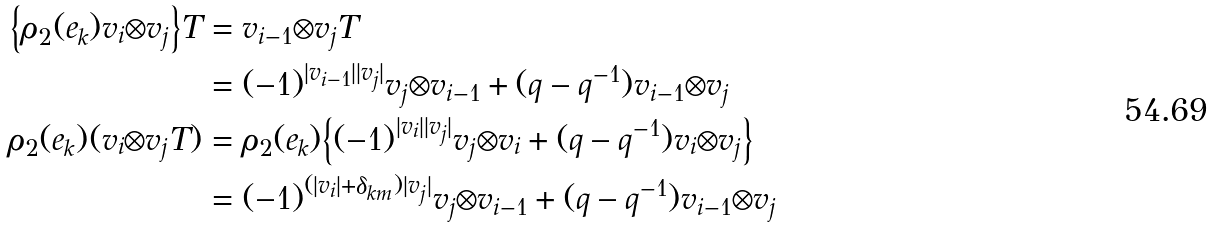Convert formula to latex. <formula><loc_0><loc_0><loc_500><loc_500>\Big { \{ } \rho _ { 2 } ( e _ { k } ) v _ { i } { \otimes } v _ { j } \Big { \} } T & = v _ { i - 1 } { \otimes } v _ { j } T \\ & = ( - 1 ) ^ { | v _ { i - 1 } | | v _ { j } | } v _ { j } { \otimes } v _ { i - 1 } + ( q - q ^ { - 1 } ) v _ { i - 1 } { \otimes } v _ { j } \\ \rho _ { 2 } ( e _ { k } ) ( v _ { i } { \otimes } v _ { j } T ) & = \rho _ { 2 } ( e _ { k } ) \Big { \{ } ( - 1 ) ^ { | v _ { i } | | v _ { j } | } v _ { j } { \otimes } v _ { i } + ( q - q ^ { - 1 } ) v _ { i } { \otimes } v _ { j } \Big { \} } \\ & = ( - 1 ) ^ { ( | v _ { i } | + \delta _ { k m } ) | v _ { j } | } v _ { j } { \otimes } v _ { i - 1 } + ( q - q ^ { - 1 } ) v _ { i - 1 } { \otimes } v _ { j }</formula> 